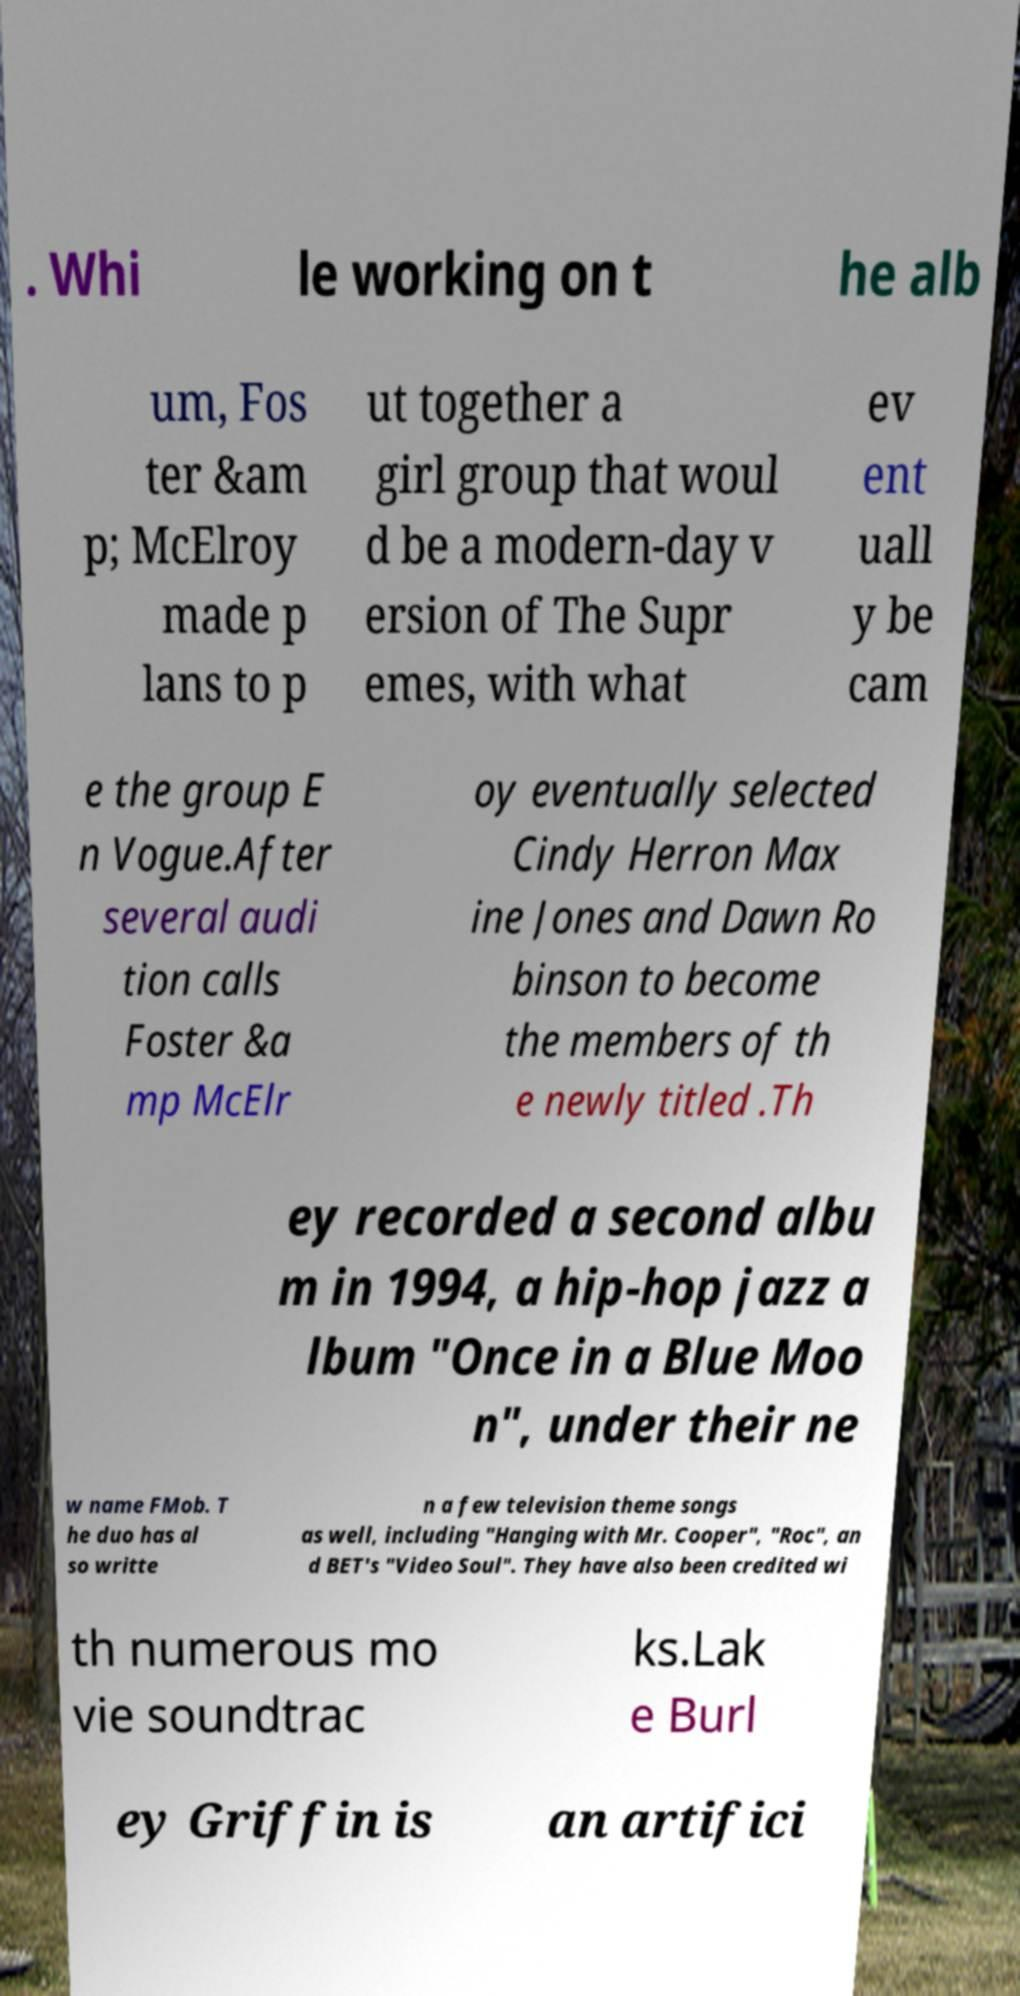What messages or text are displayed in this image? I need them in a readable, typed format. . Whi le working on t he alb um, Fos ter &am p; McElroy made p lans to p ut together a girl group that woul d be a modern-day v ersion of The Supr emes, with what ev ent uall y be cam e the group E n Vogue.After several audi tion calls Foster &a mp McElr oy eventually selected Cindy Herron Max ine Jones and Dawn Ro binson to become the members of th e newly titled .Th ey recorded a second albu m in 1994, a hip-hop jazz a lbum "Once in a Blue Moo n", under their ne w name FMob. T he duo has al so writte n a few television theme songs as well, including "Hanging with Mr. Cooper", "Roc", an d BET's "Video Soul". They have also been credited wi th numerous mo vie soundtrac ks.Lak e Burl ey Griffin is an artifici 